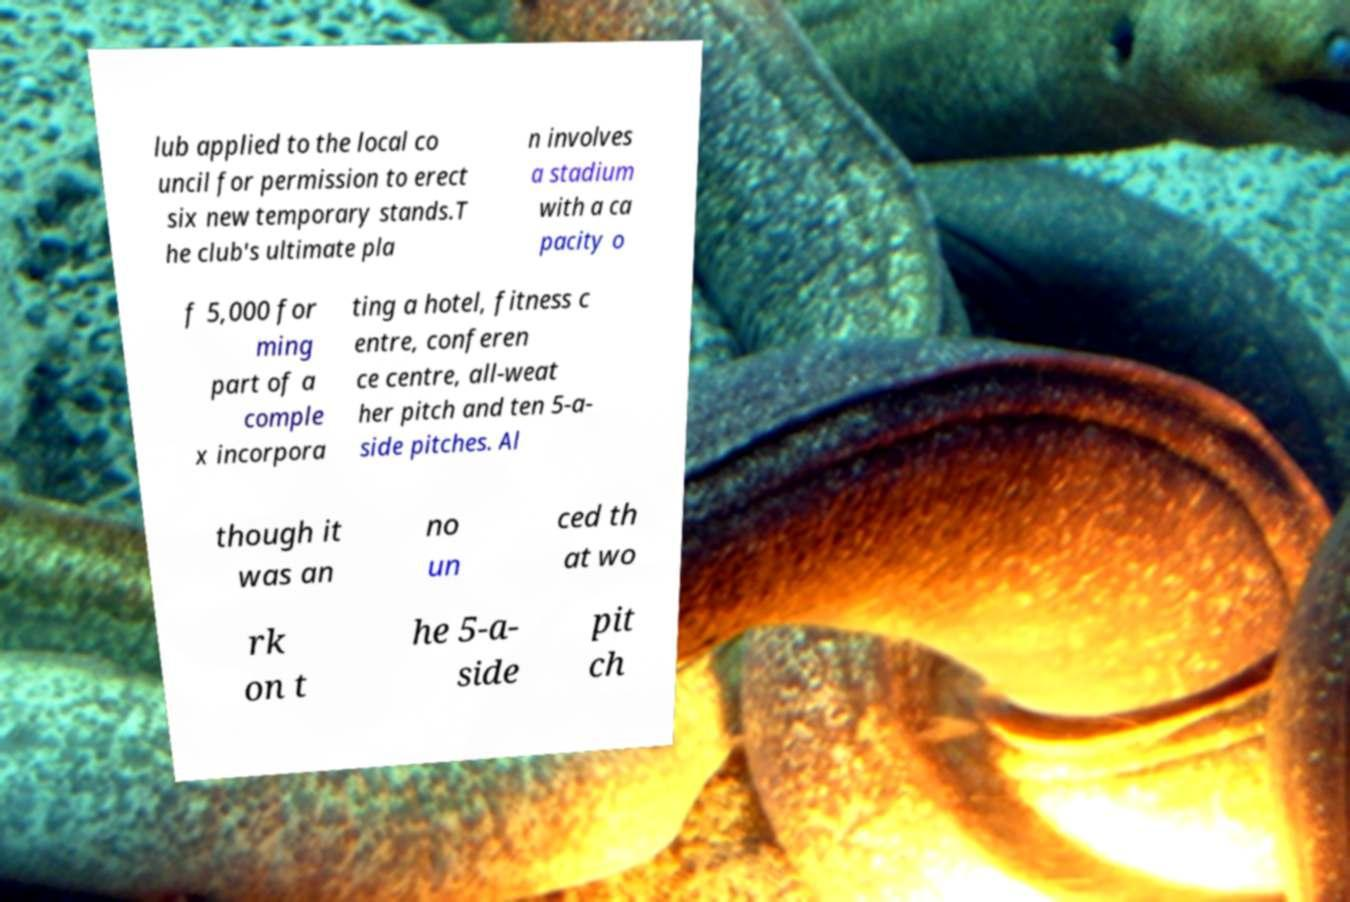For documentation purposes, I need the text within this image transcribed. Could you provide that? lub applied to the local co uncil for permission to erect six new temporary stands.T he club's ultimate pla n involves a stadium with a ca pacity o f 5,000 for ming part of a comple x incorpora ting a hotel, fitness c entre, conferen ce centre, all-weat her pitch and ten 5-a- side pitches. Al though it was an no un ced th at wo rk on t he 5-a- side pit ch 